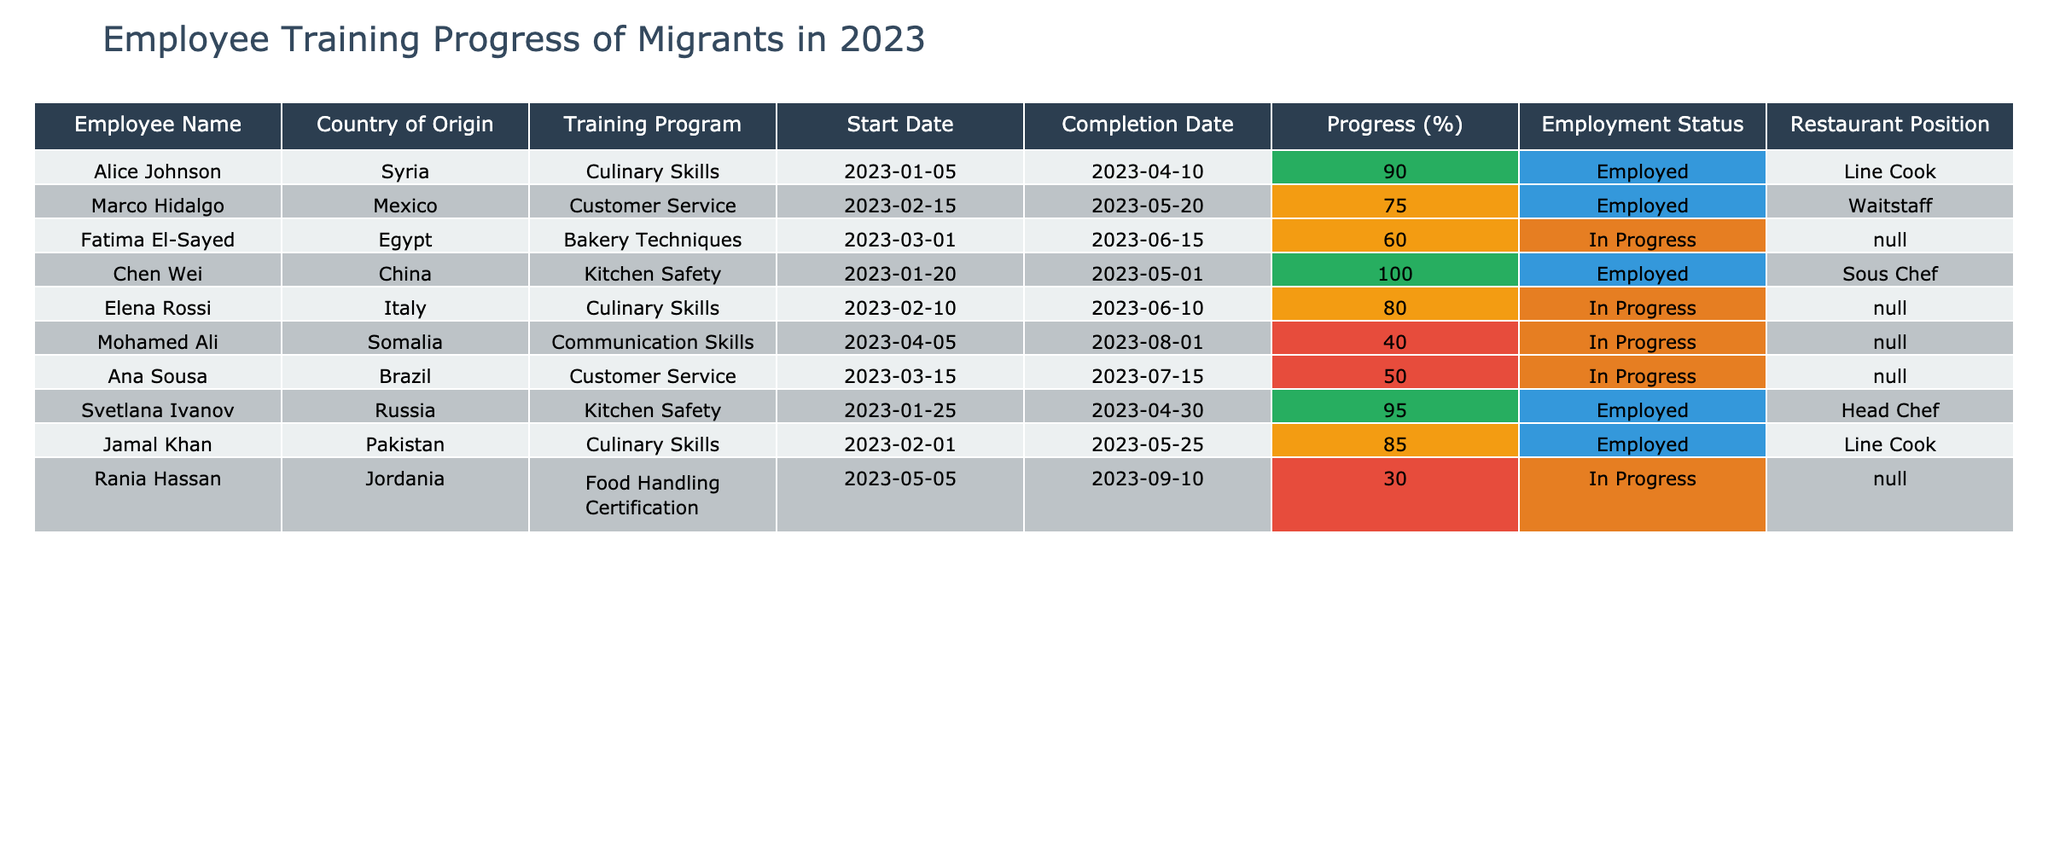What is the name of the employee from Egypt? The table lists "Fatima El-Sayed" as the employee with the country of origin being Egypt.
Answer: Fatima El-Sayed How many employees have completed their training program? The employees who have completed their training program are Alice Johnson, Chen Wei, and Svetlana Ivanov. That's a total of 3 employees.
Answer: 3 Which employee has the highest training progress? Chen Wei has a training progress of 100%, which is the highest among all employees listed.
Answer: Chen Wei Is Rania Hassan currently employed? The table shows that Rania Hassan's employment status is "In Progress," indicating she is not currently employed.
Answer: No What is the average training progress of all employees? The training progress values are 90, 75, 60, 100, 80, 40, 50, 95, 85, and 30. By adding these values (90 + 75 + 60 + 100 + 80 + 40 + 50 + 95 + 85 + 30 = 765) and dividing by 10 (the number of employees), the average progress is 765/10 = 76.5.
Answer: 76.5 How many employees are completely trained and employed? Only Chen Wei has completed the training and is employed. Thus, there is 1 employee in this category.
Answer: 1 What percentage of the employees are still in progress with their training? The employees still in progress include Fatima El-Sayed, Elena Rossi, Mohamed Ali, Ana Sousa, and Rania Hassan, totaling 5 employees out of 10. The percentage is (5/10) * 100 = 50%.
Answer: 50% Which training program has the lowest progress percentage among the employees? Ana Sousa is in the "Customer Service" training program with a progress percentage of 50%, which is the lowest in the table compared to others.
Answer: Customer Service Are there more employees from Syria or from Mexico? The table shows 1 employee from Syria (Alice Johnson) and 1 employee from Mexico (Marco Hidalgo); therefore, they have the same count.
Answer: Equal What is the employment status of the employee named Jamal Khan? The table indicates that Jamal Khan is "Employed."
Answer: Employed Which culinary skills program employee has the least progress? Jamal Khan has completed 85% and Alice Johnson has 90%. Therefore, Jamal Khan has the least progress in the Culinary Skills program.
Answer: Jamal Khan 